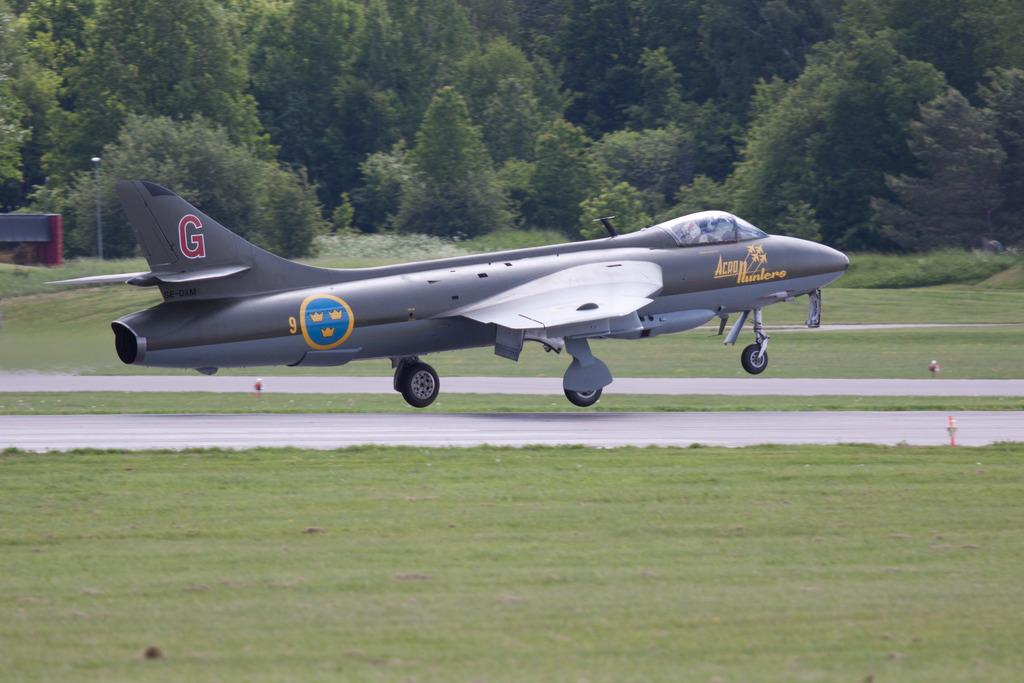Provide a one-sentence caption for the provided image. A small military jet marked Acro Hunters is landing or taking off. 